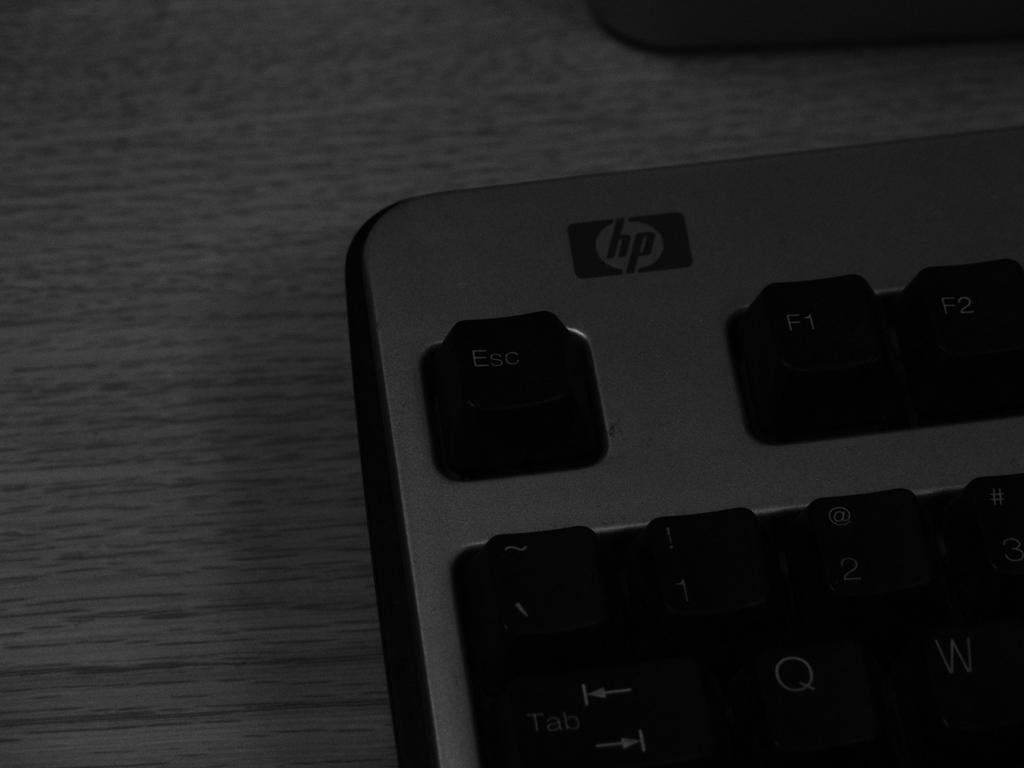<image>
Describe the image concisely. A black Esc key is visable on the hp keyboard. 